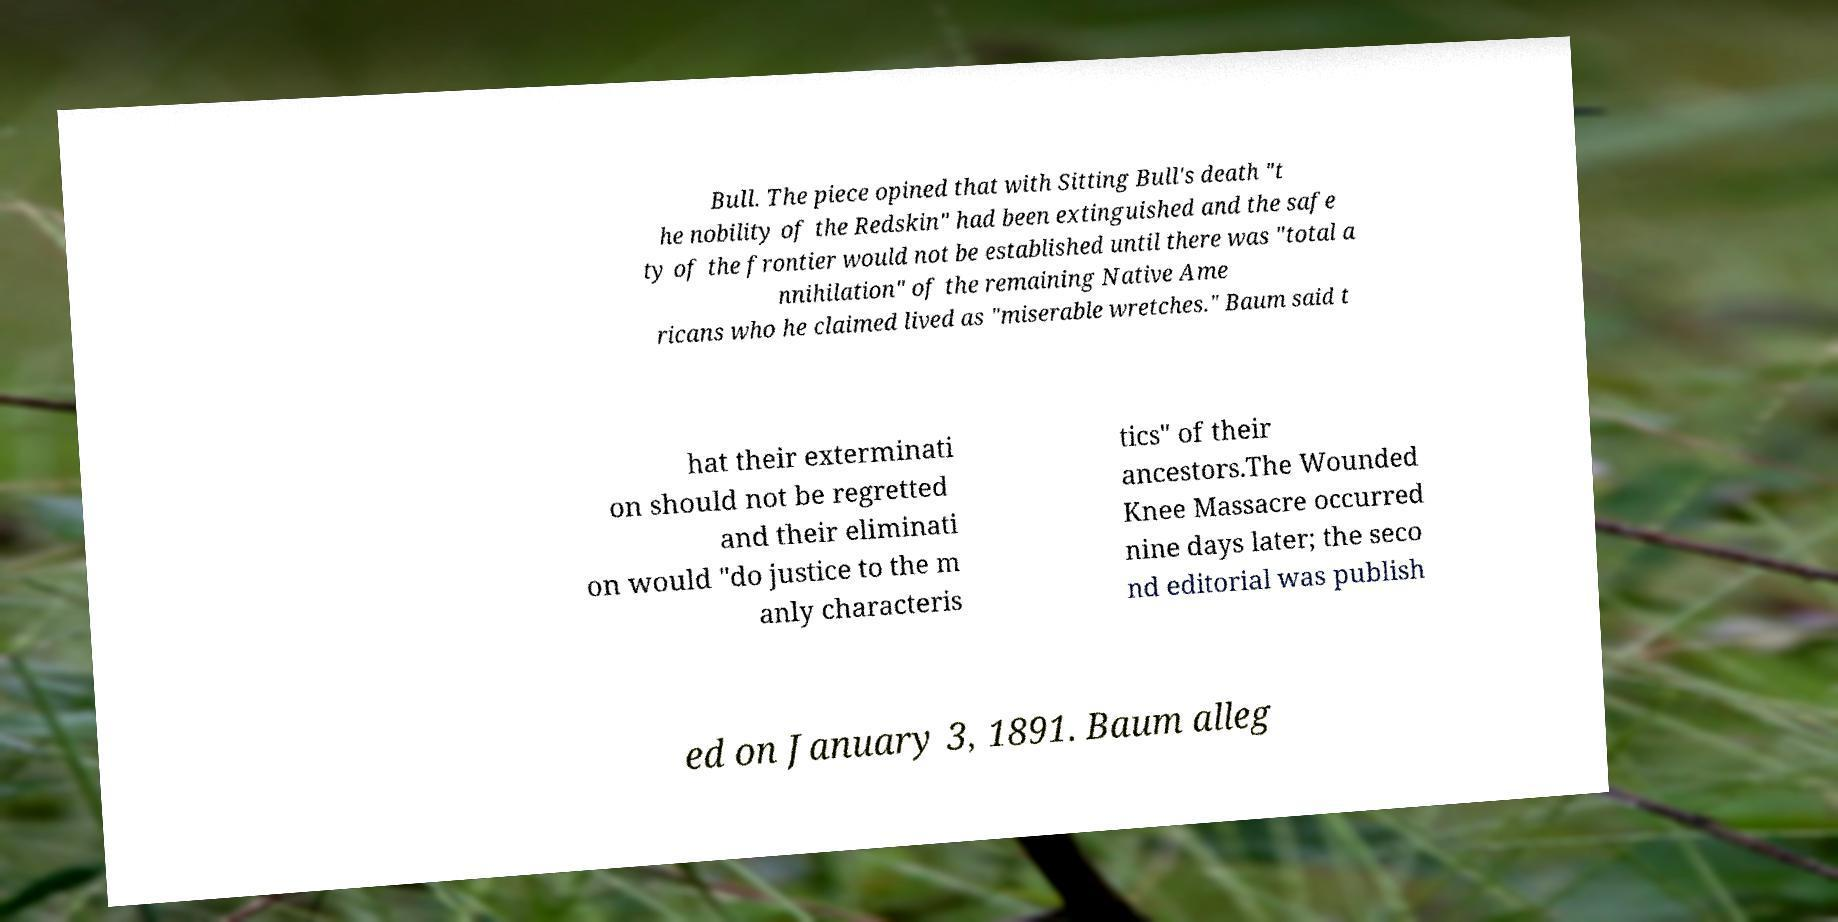Please identify and transcribe the text found in this image. Bull. The piece opined that with Sitting Bull's death "t he nobility of the Redskin" had been extinguished and the safe ty of the frontier would not be established until there was "total a nnihilation" of the remaining Native Ame ricans who he claimed lived as "miserable wretches." Baum said t hat their exterminati on should not be regretted and their eliminati on would "do justice to the m anly characteris tics" of their ancestors.The Wounded Knee Massacre occurred nine days later; the seco nd editorial was publish ed on January 3, 1891. Baum alleg 